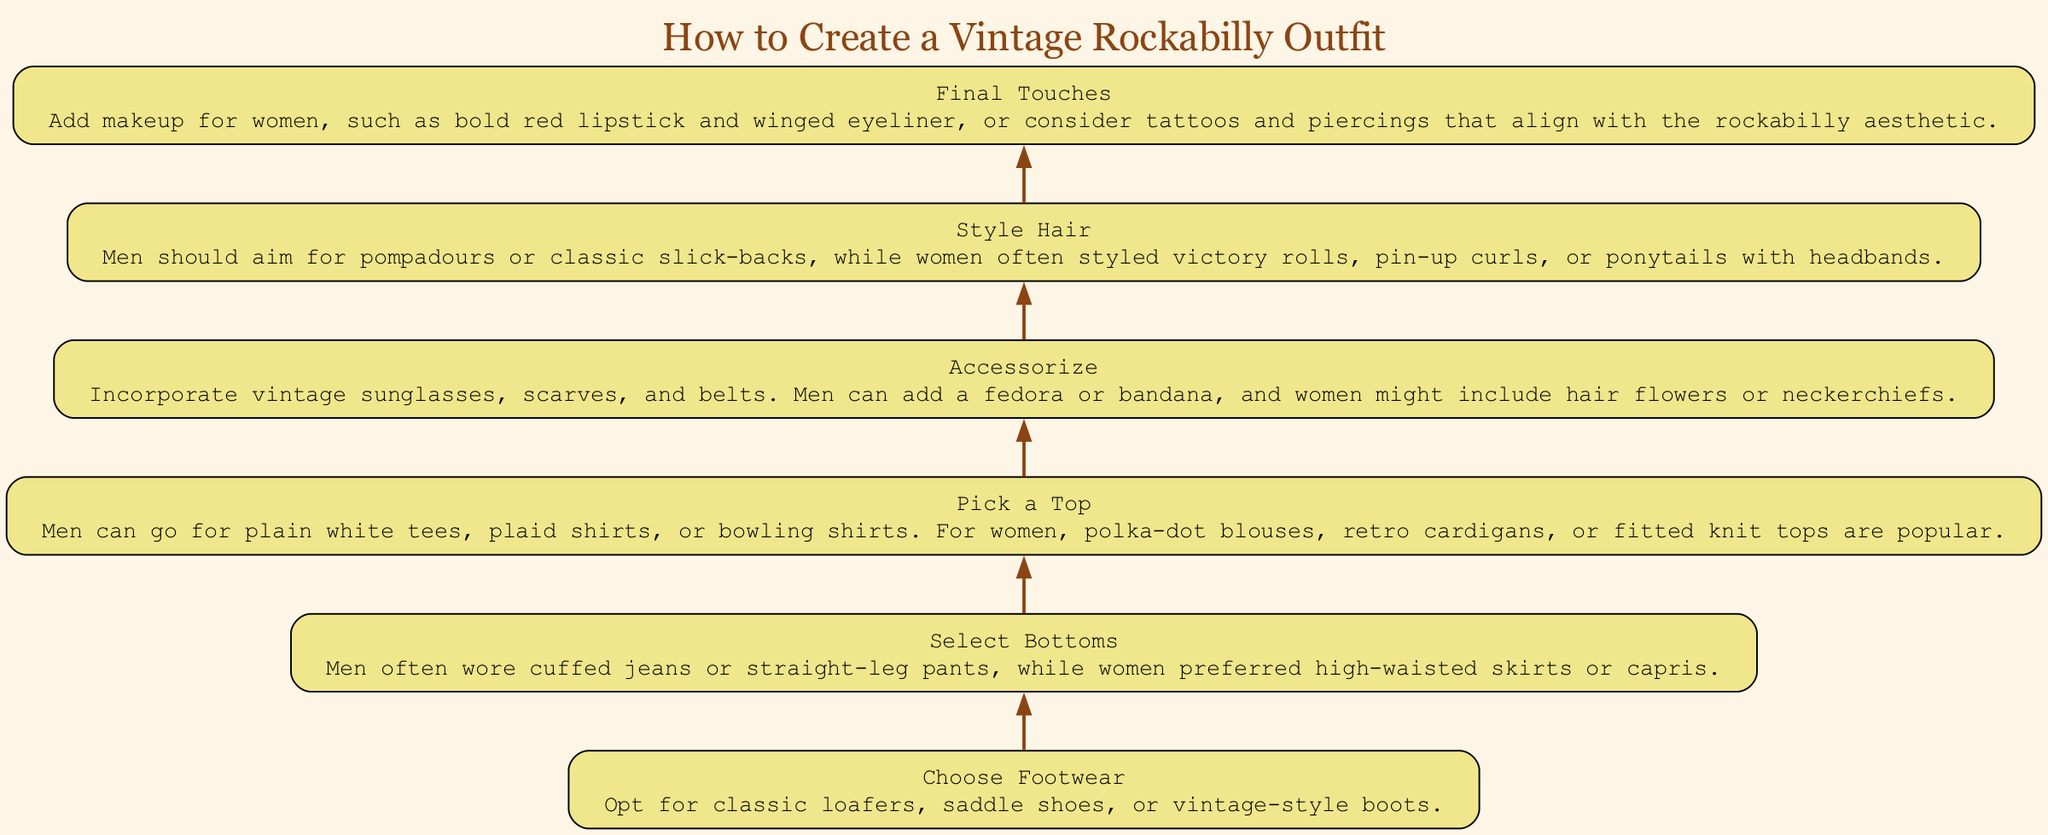What is the final step in creating a vintage rockabilly outfit? The final step in the diagram indicates "Final Touches," which involves adding makeup or considering tattoos and piercings.
Answer: Final Touches How many main steps are there in the diagram? By counting the individual steps in the flow chart, we find there are six main steps listed from bottom to top.
Answer: 6 What should men style their hair as per the diagram? According to the diagram, men should style their hair into pompadours or classic slick-backs.
Answer: Pompadours or classic slick-backs What is the first step to create the outfit? The first step in the flow chart is "Choose Footwear," which suggests various options for shoes.
Answer: Choose Footwear Which accessory is specifically mentioned for women? The diagram states that women might include hair flowers or neckerchiefs as part of their accessories.
Answer: Hair flowers or neckerchiefs What type of tops can men pick according to the chart? The diagram mentions that men can choose from plain white tees, plaid shirts, or bowling shirts as options for tops.
Answer: Plain white tees, plaid shirts, or bowling shirts Which step mentions specific bottoms for men and women? The step titled "Select Bottoms" discusses the types of bottoms traditionally worn by men and women in the rockabilly style.
Answer: Select Bottoms What should be added during the "Final Touches"? The final touches involve adding makeup for women, including bold red lipstick and winged eyeliner, or considering tattoos and piercings.
Answer: Bold red lipstick and winged eyeliner, tattoos and piercings What type of sunglasses is suggested in the accessorizing step? The diagram suggests incorporating vintage sunglasses as part of the accessories for the outfit.
Answer: Vintage sunglasses 